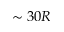Convert formula to latex. <formula><loc_0><loc_0><loc_500><loc_500>\sim 3 0 R</formula> 